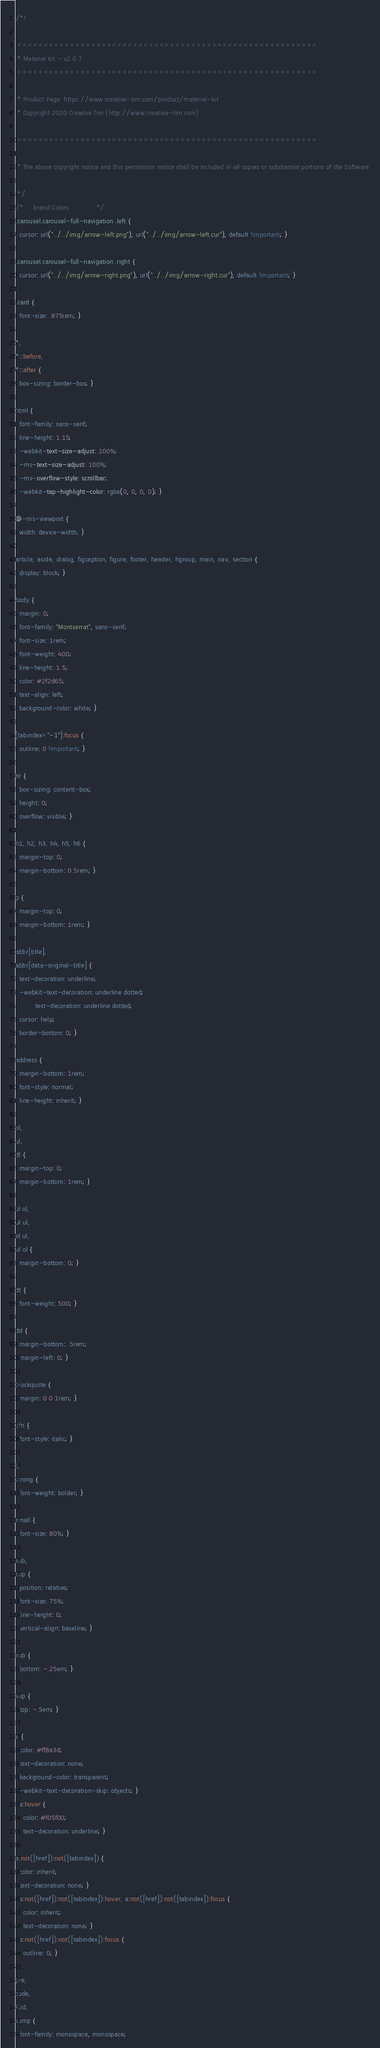<code> <loc_0><loc_0><loc_500><loc_500><_CSS_>/*!

 =========================================================
 * Material Kit - v2.0.7
 =========================================================

 * Product Page: https://www.creative-tim.com/product/material-kit
 * Copyright 2020 Creative Tim (http://www.creative-tim.com)

 =========================================================

 * The above copyright notice and this permission notice shall be included in all copies or substantial portions of the Software.

 */
/*     brand Colors              */
.carousel.carousel-full-navigation .left {
  cursor: url("../../img/arrow-left.png"), url("../../img/arrow-left.cur"), default !important; }

.carousel.carousel-full-navigation .right {
  cursor: url("../../img/arrow-right.png"), url("../../img/arrow-right.cur"), default !important; }

.card {
  font-size: .875rem; }

*,
*::before,
*::after {
  box-sizing: border-box; }

html {
  font-family: sans-serif;
  line-height: 1.15;
  -webkit-text-size-adjust: 100%;
  -ms-text-size-adjust: 100%;
  -ms-overflow-style: scrollbar;
  -webkit-tap-highlight-color: rgba(0, 0, 0, 0); }

@-ms-viewport {
  width: device-width; }

article, aside, dialog, figcaption, figure, footer, header, hgroup, main, nav, section {
  display: block; }

body {
  margin: 0;
  font-family: "Montserrat", sans-serif;
  font-size: 1rem;
  font-weight: 400;
  line-height: 1.5;
  color: #2f2d65;
  text-align: left;
  background-color: white; }

[tabindex="-1"]:focus {
  outline: 0 !important; }

hr {
  box-sizing: content-box;
  height: 0;
  overflow: visible; }

h1, h2, h3, h4, h5, h6 {
  margin-top: 0;
  margin-bottom: 0.5rem; }

p {
  margin-top: 0;
  margin-bottom: 1rem; }

abbr[title],
abbr[data-original-title] {
  text-decoration: underline;
  -webkit-text-decoration: underline dotted;
          text-decoration: underline dotted;
  cursor: help;
  border-bottom: 0; }

address {
  margin-bottom: 1rem;
  font-style: normal;
  line-height: inherit; }

ol,
ul,
dl {
  margin-top: 0;
  margin-bottom: 1rem; }

ol ol,
ul ul,
ol ul,
ul ol {
  margin-bottom: 0; }

dt {
  font-weight: 500; }

dd {
  margin-bottom: .5rem;
  margin-left: 0; }

blockquote {
  margin: 0 0 1rem; }

dfn {
  font-style: italic; }

b,
strong {
  font-weight: bolder; }

small {
  font-size: 80%; }

sub,
sup {
  position: relative;
  font-size: 75%;
  line-height: 0;
  vertical-align: baseline; }

sub {
  bottom: -.25em; }

sup {
  top: -.5em; }

a {
  color: #ff8a3d;
  text-decoration: none;
  background-color: transparent;
  -webkit-text-decoration-skip: objects; }
  a:hover {
    color: #f05f00;
    text-decoration: underline; }

a:not([href]):not([tabindex]) {
  color: inherit;
  text-decoration: none; }
  a:not([href]):not([tabindex]):hover, a:not([href]):not([tabindex]):focus {
    color: inherit;
    text-decoration: none; }
  a:not([href]):not([tabindex]):focus {
    outline: 0; }

pre,
code,
kbd,
samp {
  font-family: monospace, monospace;</code> 